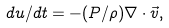<formula> <loc_0><loc_0><loc_500><loc_500>d u / d t = - ( P / \rho ) \nabla \cdot \vec { v } ,</formula> 